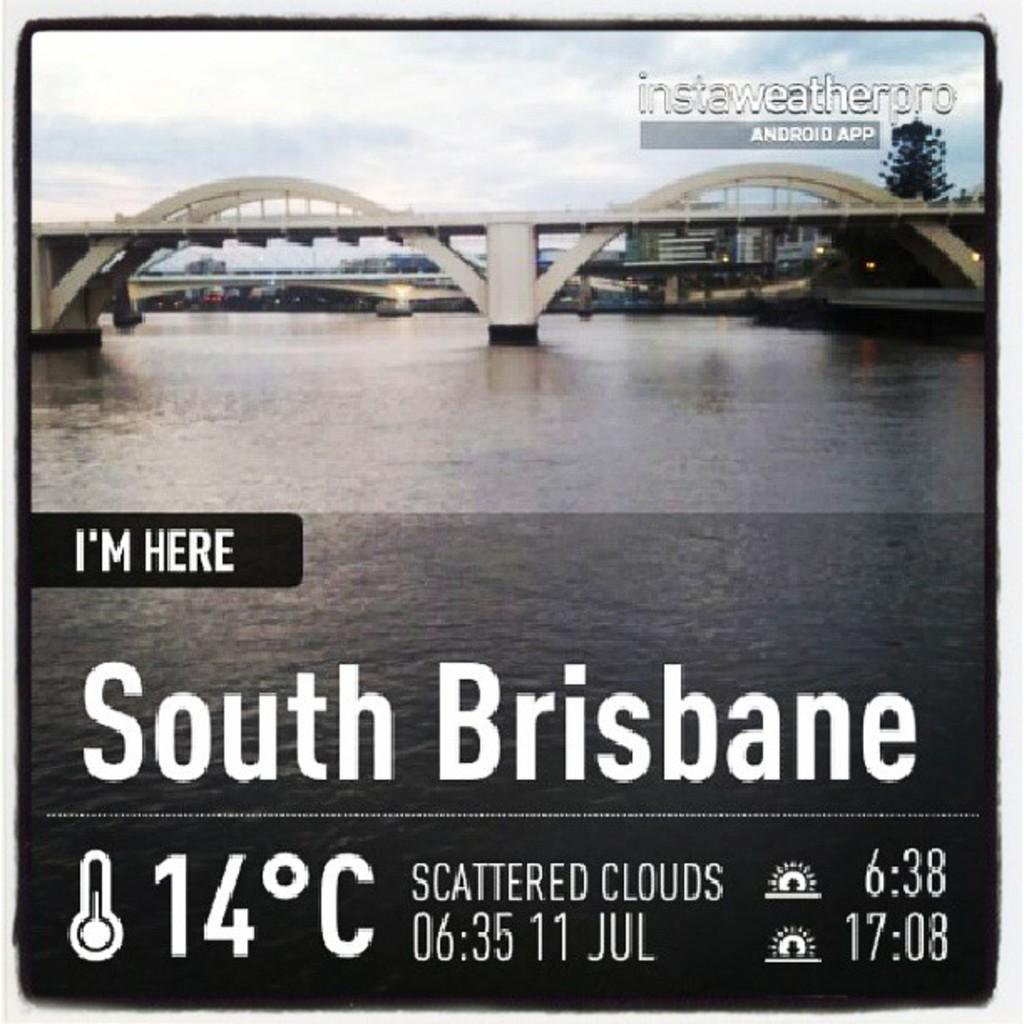<image>
Write a terse but informative summary of the picture. A picture of a bridge in the background with text claiming that I'm here. 